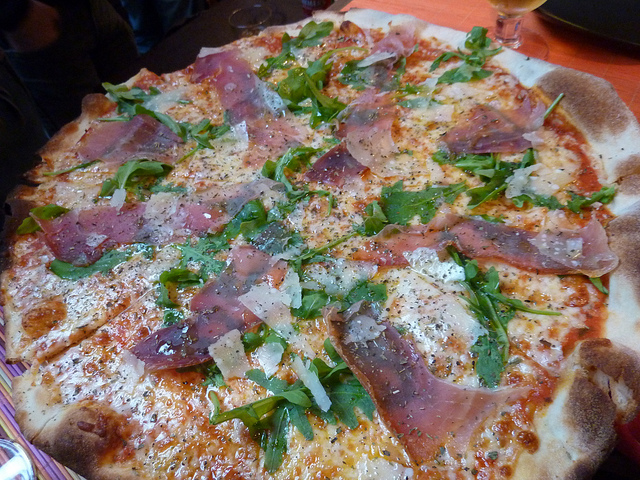<image>What pizza type is this? It is ambiguous what type of pizza this is. It could be salami, prosciutto, ham and parsley, cheese, margarita, vegetarian or more. What pizza type is this? It is ambiguous what pizza type this is. It could be 'salami', 'prosciutto', 'ham and parsley', 'meat', 'bacon', 'margarita', 'cheese', 'ham and spinach' or 'vegetarian pizza'. 